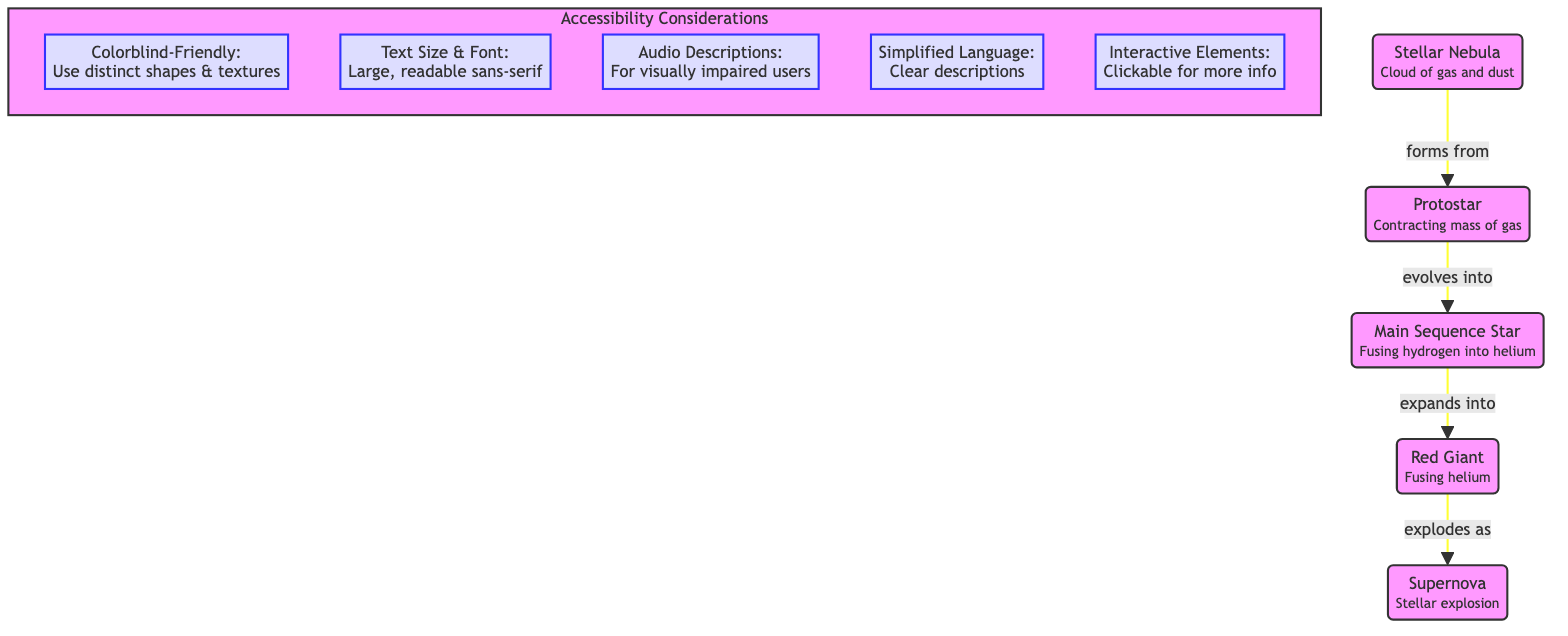What is the initial stage of a star's lifecycle? The diagram indicates that the lifecycle starts with a "Stellar Nebula," which is the first node.
Answer: Stellar Nebula What forms after the Stellar Nebula? The arrow in the diagram shows that the Stellar Nebula evolves into a "Protostar," indicating this transformation.
Answer: Protostar How many main stages are represented in the star lifecycle? By counting the main nodes in the diagram, which are Stellar Nebula, Protostar, Main Sequence Star, Red Giant, and Supernova, we find there are five stages.
Answer: 5 What does a Red Giant do in the lifecycle of a star? According to the diagram, the Red Giant node is labeled with "Fusing helium," showing its function during this stage.
Answer: Fusing helium Which stage comes just before the Supernova? The diagram shows an arrow leading from the Red Giant to the Supernova, indicating that the Red Giant stage is directly before the Supernova.
Answer: Red Giant What is one accessibility consideration mentioned in the diagram? The diagram outlines several accessibility considerations; one of them is "Colorblind-Friendly: Use distinct shapes & textures."
Answer: Colorblind-Friendly: Use distinct shapes & textures How does a Protostar transition to a Main Sequence Star? The diagram displays an arrow pointing from the Protostar to the Main Sequence Star, labeled with "evolves into," explaining this transition.
Answer: Evolves into What structure does the Supernova stage have according to the diagram? The diagram illustrates the Supernova as a "Stellar explosion," which describes its characteristic.
Answer: Stellar explosion What should be provided for visually impaired users according to accessibility considerations? The diagram specifies "Audio Descriptions," which is one of the accessibility measures to help visually impaired users.
Answer: Audio Descriptions 